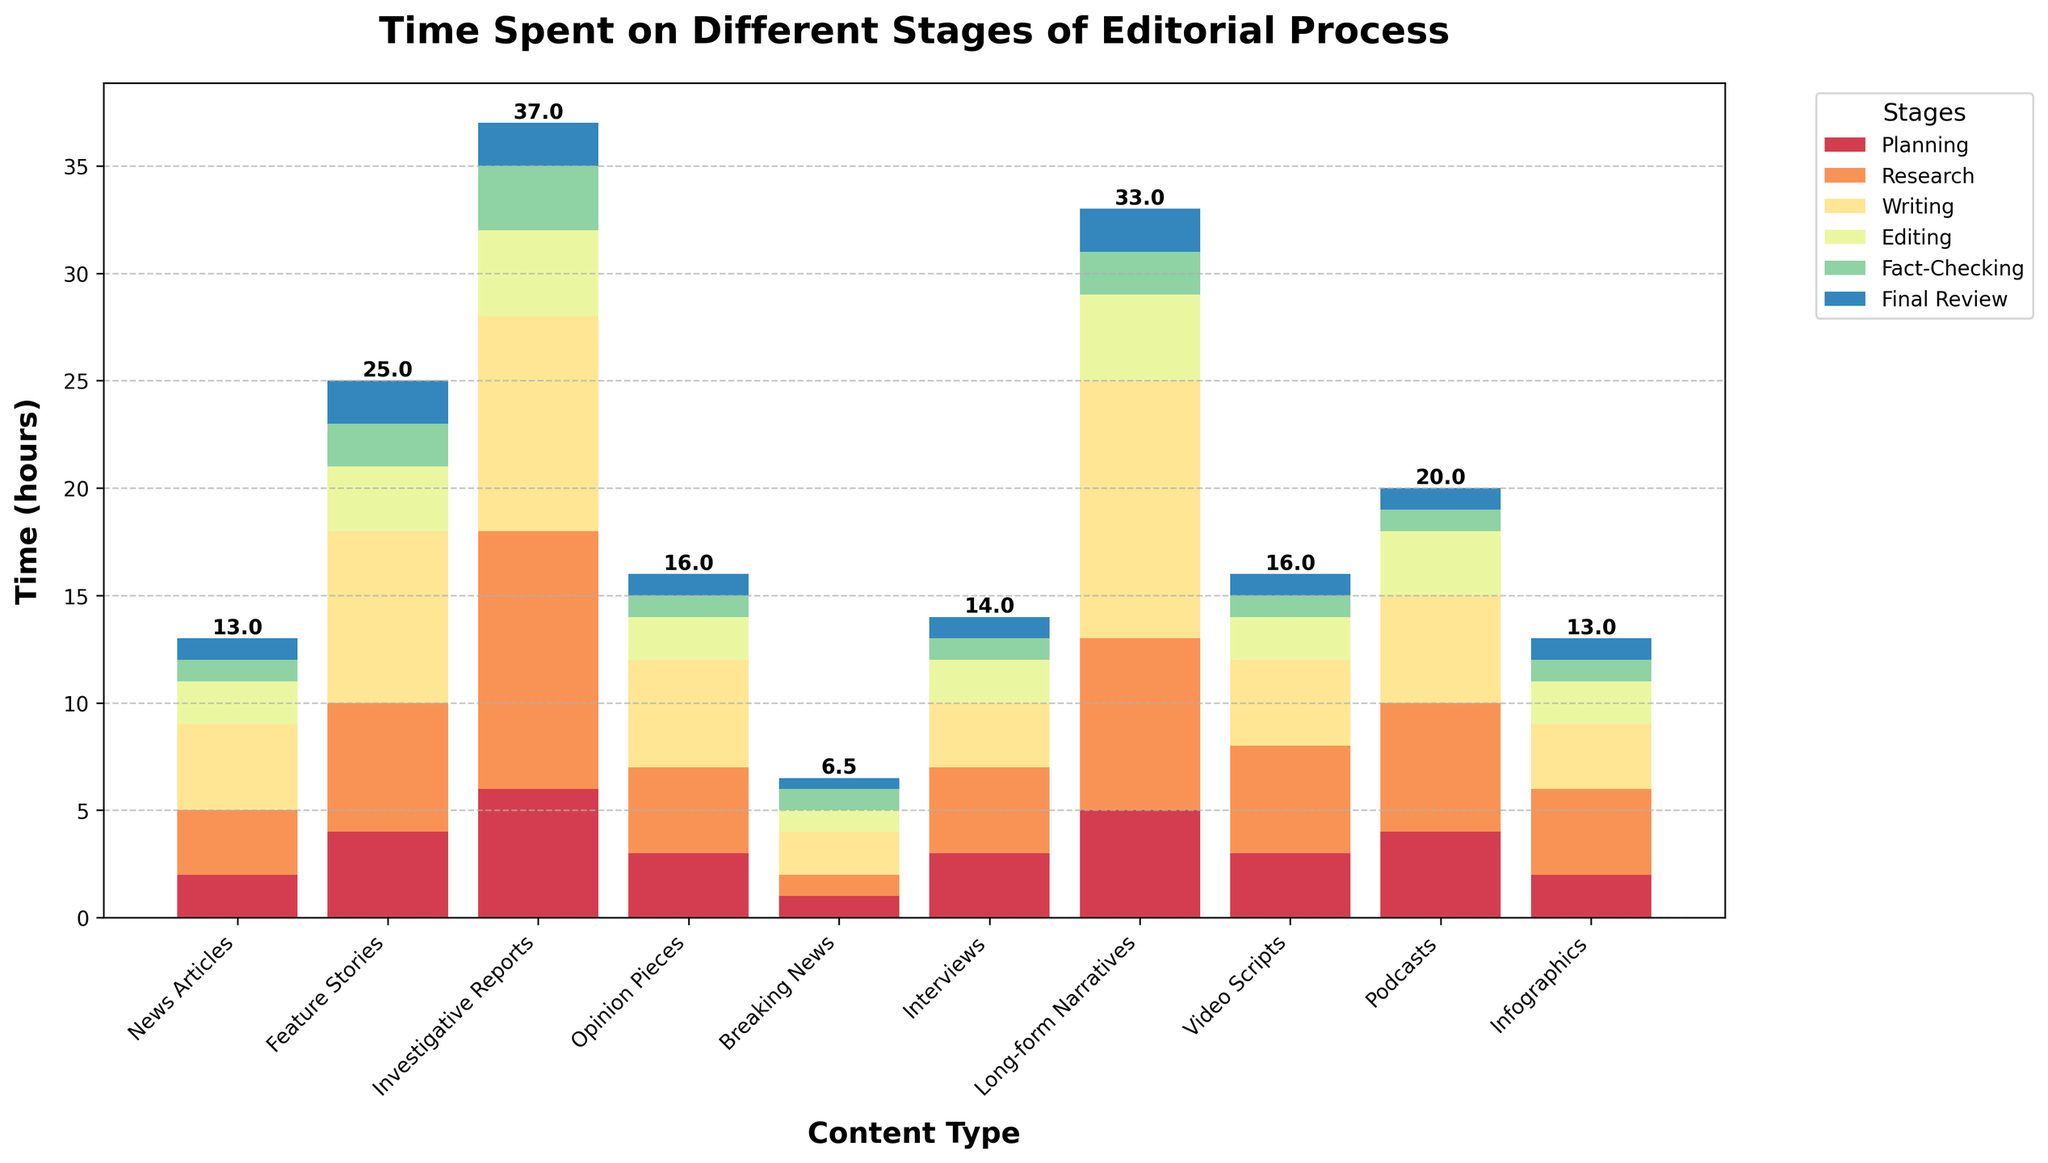Which content type spends the most time on planning? The tallest bar in the 'Planning' section indicates the highest time spent on planning. Long-form Narratives has the tallest bar for planning.
Answer: Long-form Narratives How much total time is spent on the editorial process for Feature Stories? Sum the values for all stages in Feature Stories: 4 (Planning) + 6 (Research) + 8 (Writing) + 3 (Editing) + 2 (Fact-Checking) + 2 (Final Review) = 25
Answer: 25 hours Which stage takes the least amount of time for Breaking News? Look for the shortest bar within the Breaking News group. The shortest stage bar is 'Final Review' with 0.5 hours.
Answer: Final Review Compare the time spent on editing between Investigative Reports and Video Scripts. Which one spends more, and by how much? Investigative Reports spends 4 hours on editing, while Video Scripts spend 2 hours. The difference is \(4 - 2 = 2\) hours.
Answer: Investigative Reports by 2 hours What is the average time spent on writing across all content types? Calculate the average by summing the 'Writing' times and dividing by the number of content types: (4+8+10+5+2+3+12+4+5+3) = 56 hours. There are 10 content types, so \(56 / 10 = 5.6\)
Answer: 5.6 hours Which content type spends the longest time on research and how many hours? Look for the tallest bar in the 'Research' section. Investigative Reports have the highest bar, spending 12 hours.
Answer: Investigative Reports, 12 hours How much more time do Long-form Narratives spend on writing than Podcasts? Long-form Narratives spend 12 hours on writing, and Podcasts spend 5 hours. The difference is \(12 - 5 = 7\) hours.
Answer: 7 hours What color represents the Editing stage in the chart? Find the color of the bars labeled 'Editing'. The Editing stage is represented by a middle color in the gradient, which is likely orange/yellow.
Answer: Orange/Yellow Among the content types, which one has the lowest overall time spent, and what is the total? Analyze the total heights of all bars for each content type and identify the lowest one. Breaking News has the shortest total bar length summing up to 6.5 hours.
Answer: Breaking News, 6.5 hours 